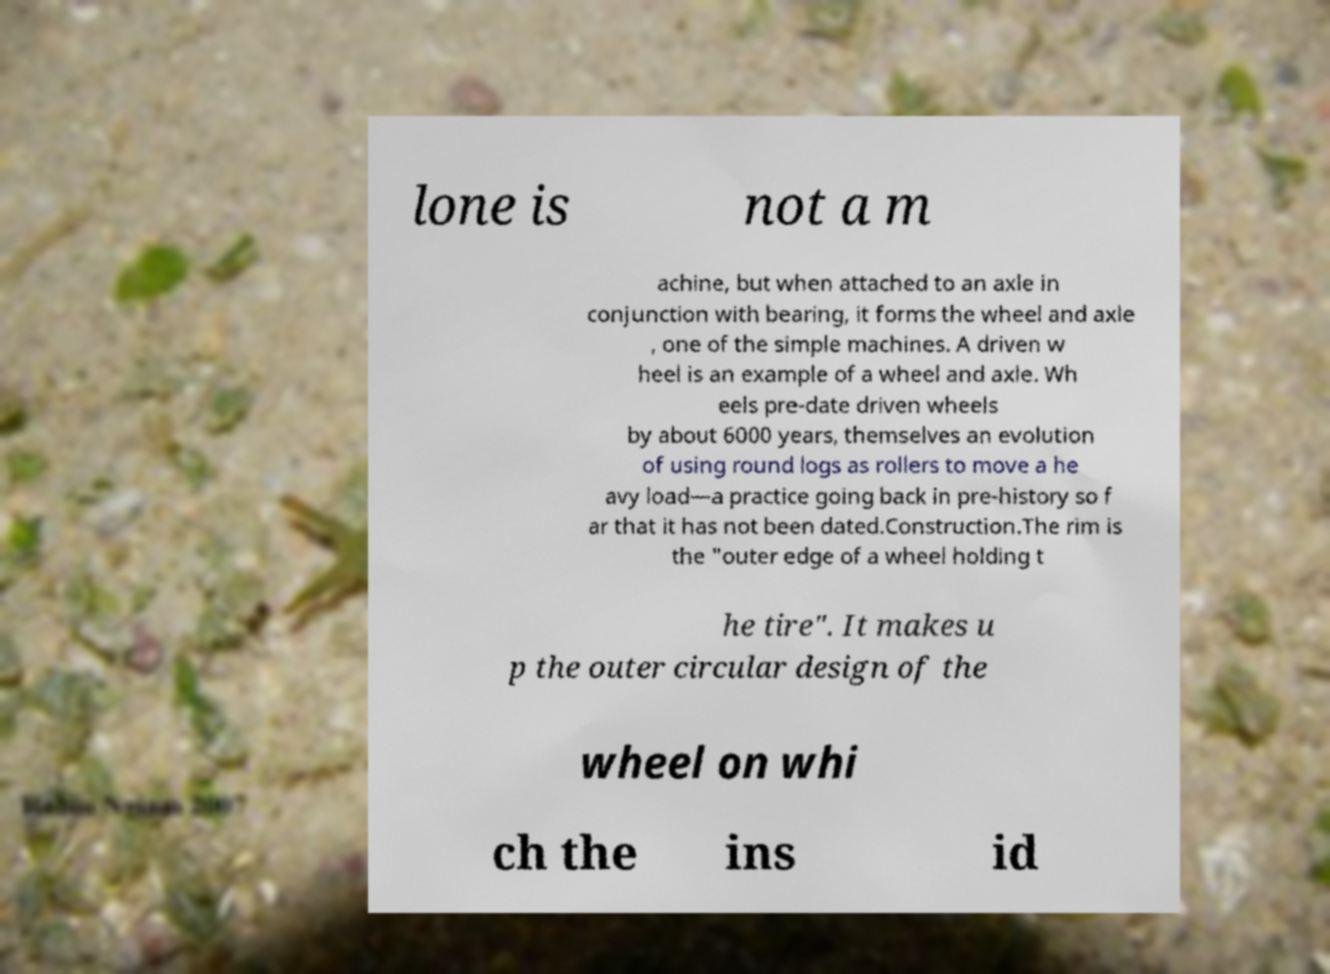Please identify and transcribe the text found in this image. lone is not a m achine, but when attached to an axle in conjunction with bearing, it forms the wheel and axle , one of the simple machines. A driven w heel is an example of a wheel and axle. Wh eels pre-date driven wheels by about 6000 years, themselves an evolution of using round logs as rollers to move a he avy load—a practice going back in pre-history so f ar that it has not been dated.Construction.The rim is the "outer edge of a wheel holding t he tire". It makes u p the outer circular design of the wheel on whi ch the ins id 